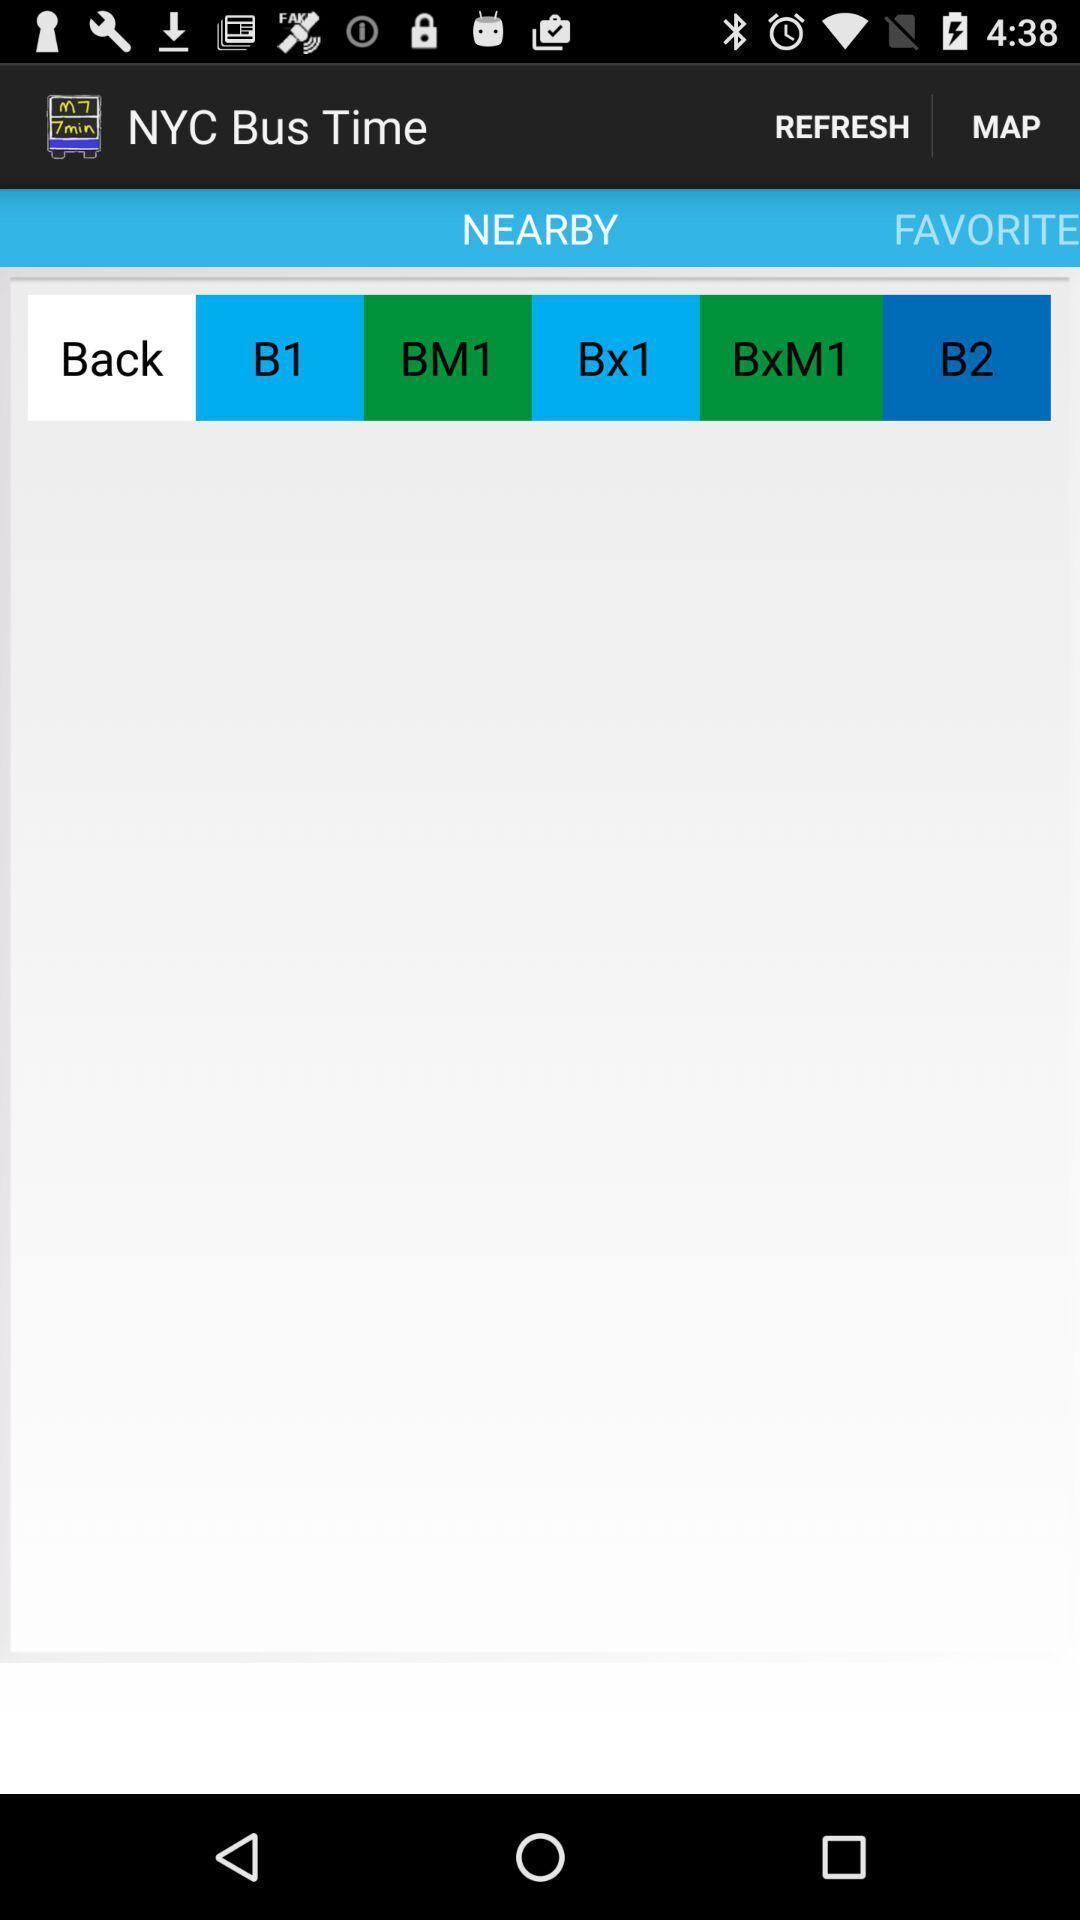Describe the key features of this screenshot. Screen showing nearby bus time. 